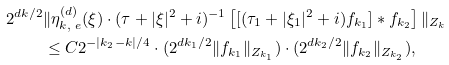Convert formula to latex. <formula><loc_0><loc_0><loc_500><loc_500>2 ^ { d k / 2 } & \| \eta _ { k , \ e } ^ { ( d ) } ( \xi ) \cdot ( \tau + | \xi | ^ { 2 } + i ) ^ { - 1 } \left [ [ ( \tau _ { 1 } + | \xi _ { 1 } | ^ { 2 } + i ) f _ { k _ { 1 } } ] \ast f _ { k _ { 2 } } \right ] \| _ { Z _ { k } } \\ & \leq C 2 ^ { - | k _ { 2 } - k | / 4 } \cdot ( 2 ^ { d k _ { 1 } / 2 } \| f _ { k _ { 1 } } \| _ { Z _ { k _ { 1 } } } ) \cdot ( 2 ^ { d k _ { 2 } / 2 } \| f _ { k _ { 2 } } \| _ { Z _ { k _ { 2 } } } ) ,</formula> 